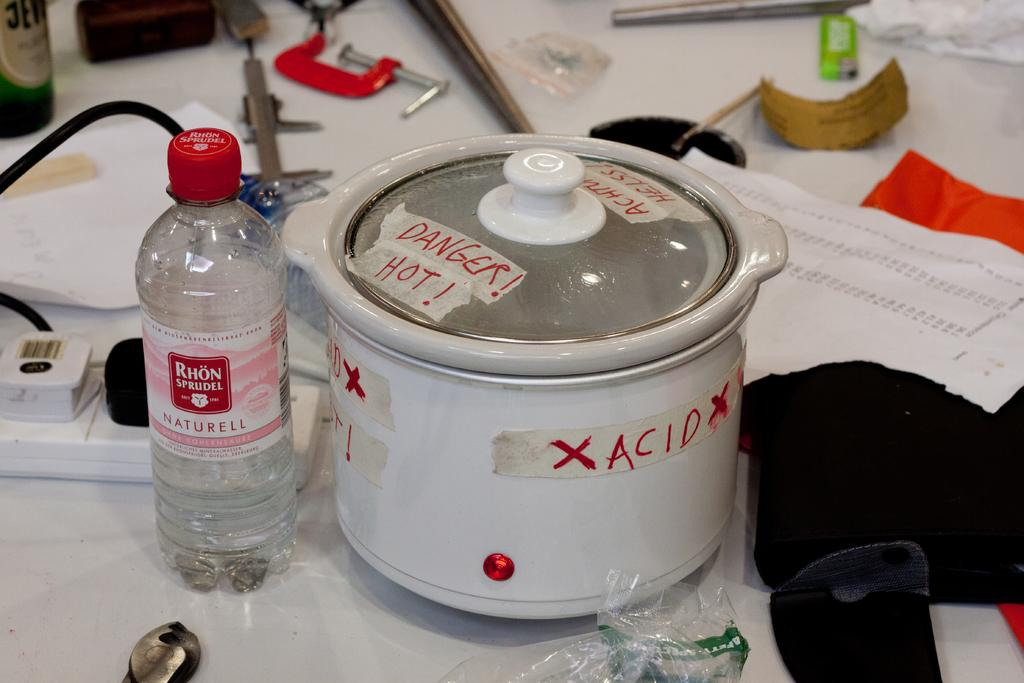What object is placed on the table in the image? There is a box on the table. What else can be seen on the table? There is a bottle, papers, and a switchboard on the table. What type of juice is being poured from the plate in the image? There is no plate or juice present in the image. 